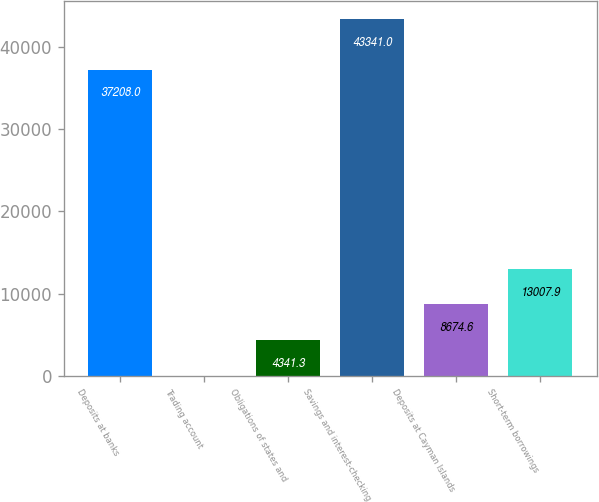Convert chart to OTSL. <chart><loc_0><loc_0><loc_500><loc_500><bar_chart><fcel>Deposits at banks<fcel>Trading account<fcel>Obligations of states and<fcel>Savings and interest-checking<fcel>Deposits at Cayman Islands<fcel>Short-term borrowings<nl><fcel>37208<fcel>8<fcel>4341.3<fcel>43341<fcel>8674.6<fcel>13007.9<nl></chart> 